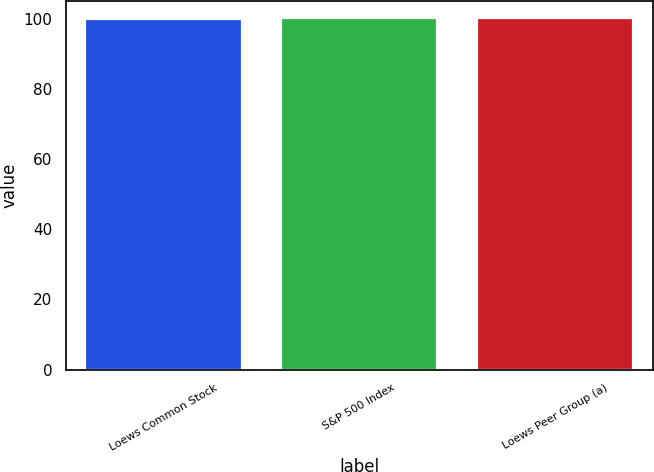<chart> <loc_0><loc_0><loc_500><loc_500><bar_chart><fcel>Loews Common Stock<fcel>S&P 500 Index<fcel>Loews Peer Group (a)<nl><fcel>100<fcel>100.1<fcel>100.2<nl></chart> 